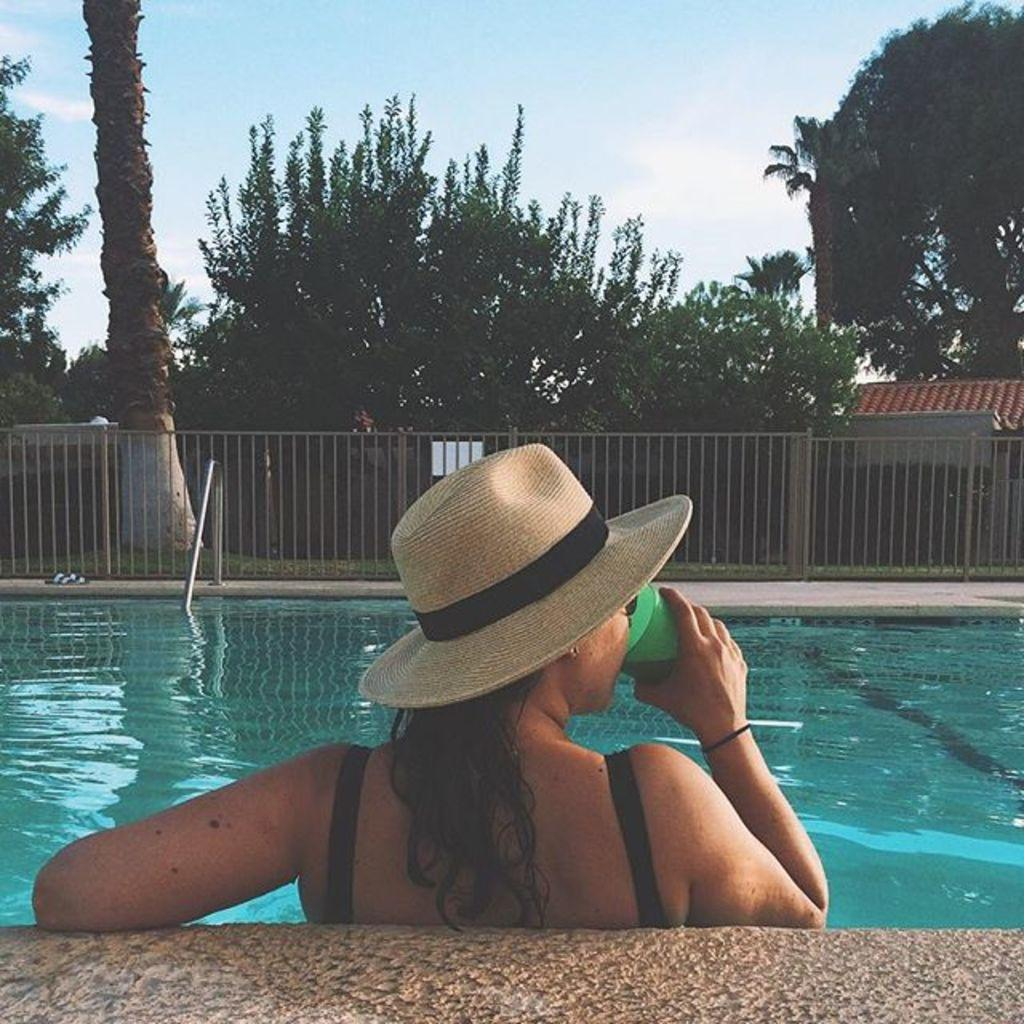Who is present in the image? There is a woman in the image. What is the woman wearing on her head? The woman is wearing a hat. Where is the woman located in the image? The woman is sitting in a swimming pool. What can be seen in the image besides the woman? There is water visible in the image, as well as a fencing grill and trees in the background. What is the aftermath of the scene depicted in the image? There is no specific scene or event taking place in the image, so it is not possible to describe an aftermath. 